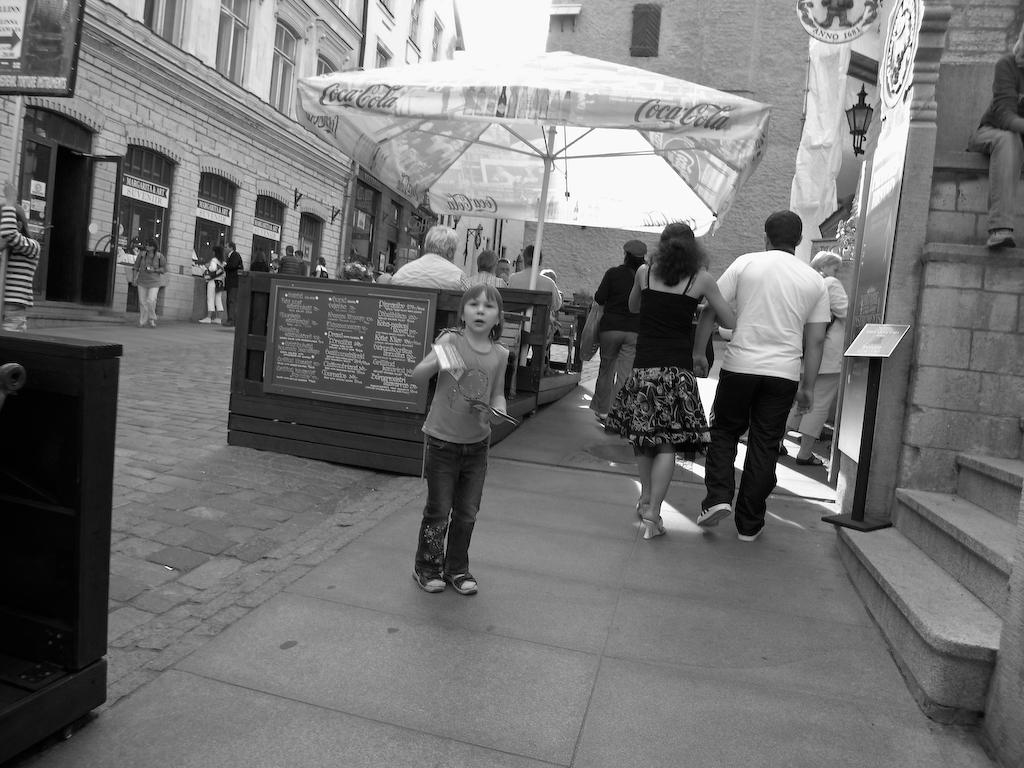Who or what can be seen in the image? There are people in the image. What object is present to provide shade? There is a parasol in the image. What type of furniture is visible in the image? There are tables in the image. What can be seen in the distance in the image? There are buildings in the background of the image, and a board is visible as well. What architectural feature is present on the right side of the image? There are stairs on the right side of the image. What type of hearing aid is being used by the person in the image? There is no hearing aid visible in the image; it is not mentioned in the provided facts. 